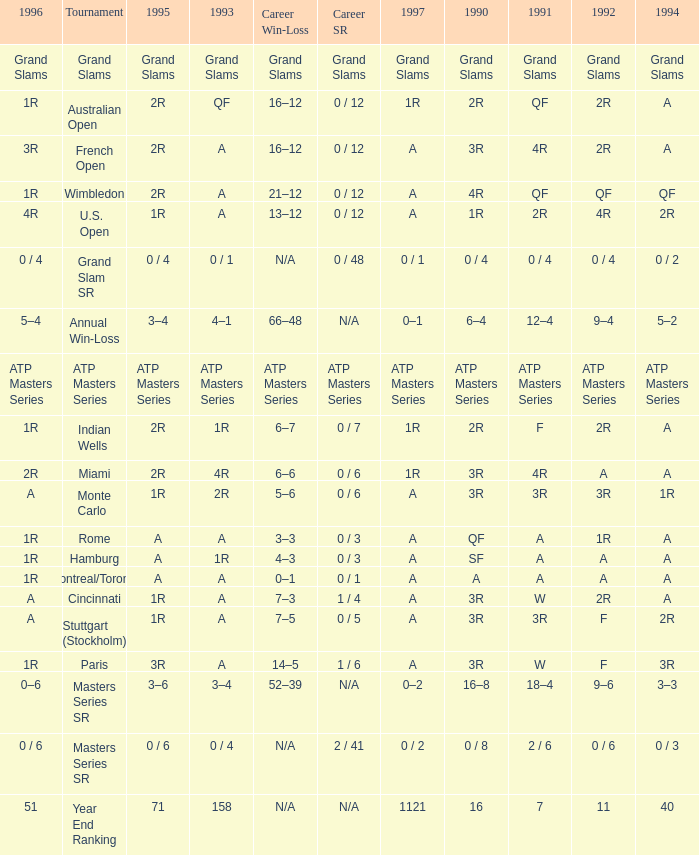What is Tournament, when Career SR is "ATP Masters Series"? ATP Masters Series. 